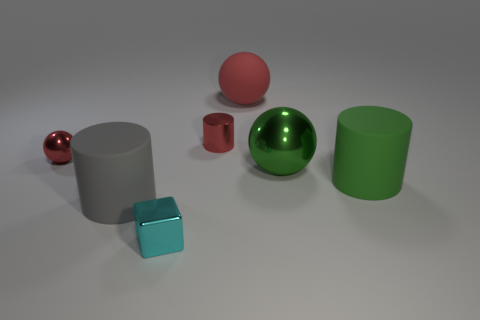How many other things are there of the same material as the tiny cube?
Your answer should be compact. 3. There is a metallic object in front of the shiny ball that is right of the gray matte cylinder; what shape is it?
Give a very brief answer. Cube. What is the size of the cylinder behind the big green cylinder?
Keep it short and to the point. Small. Does the red cylinder have the same material as the tiny cyan object?
Keep it short and to the point. Yes. There is a big thing that is made of the same material as the red cylinder; what is its shape?
Your response must be concise. Sphere. Are there any other things that have the same color as the small shiny cylinder?
Your answer should be compact. Yes. What is the color of the small object in front of the large gray cylinder?
Keep it short and to the point. Cyan. There is a big cylinder that is on the right side of the small cyan metal thing; does it have the same color as the tiny cylinder?
Provide a succinct answer. No. What material is the small red object that is the same shape as the gray rubber object?
Your answer should be very brief. Metal. What number of red metal balls have the same size as the cyan shiny block?
Give a very brief answer. 1. 